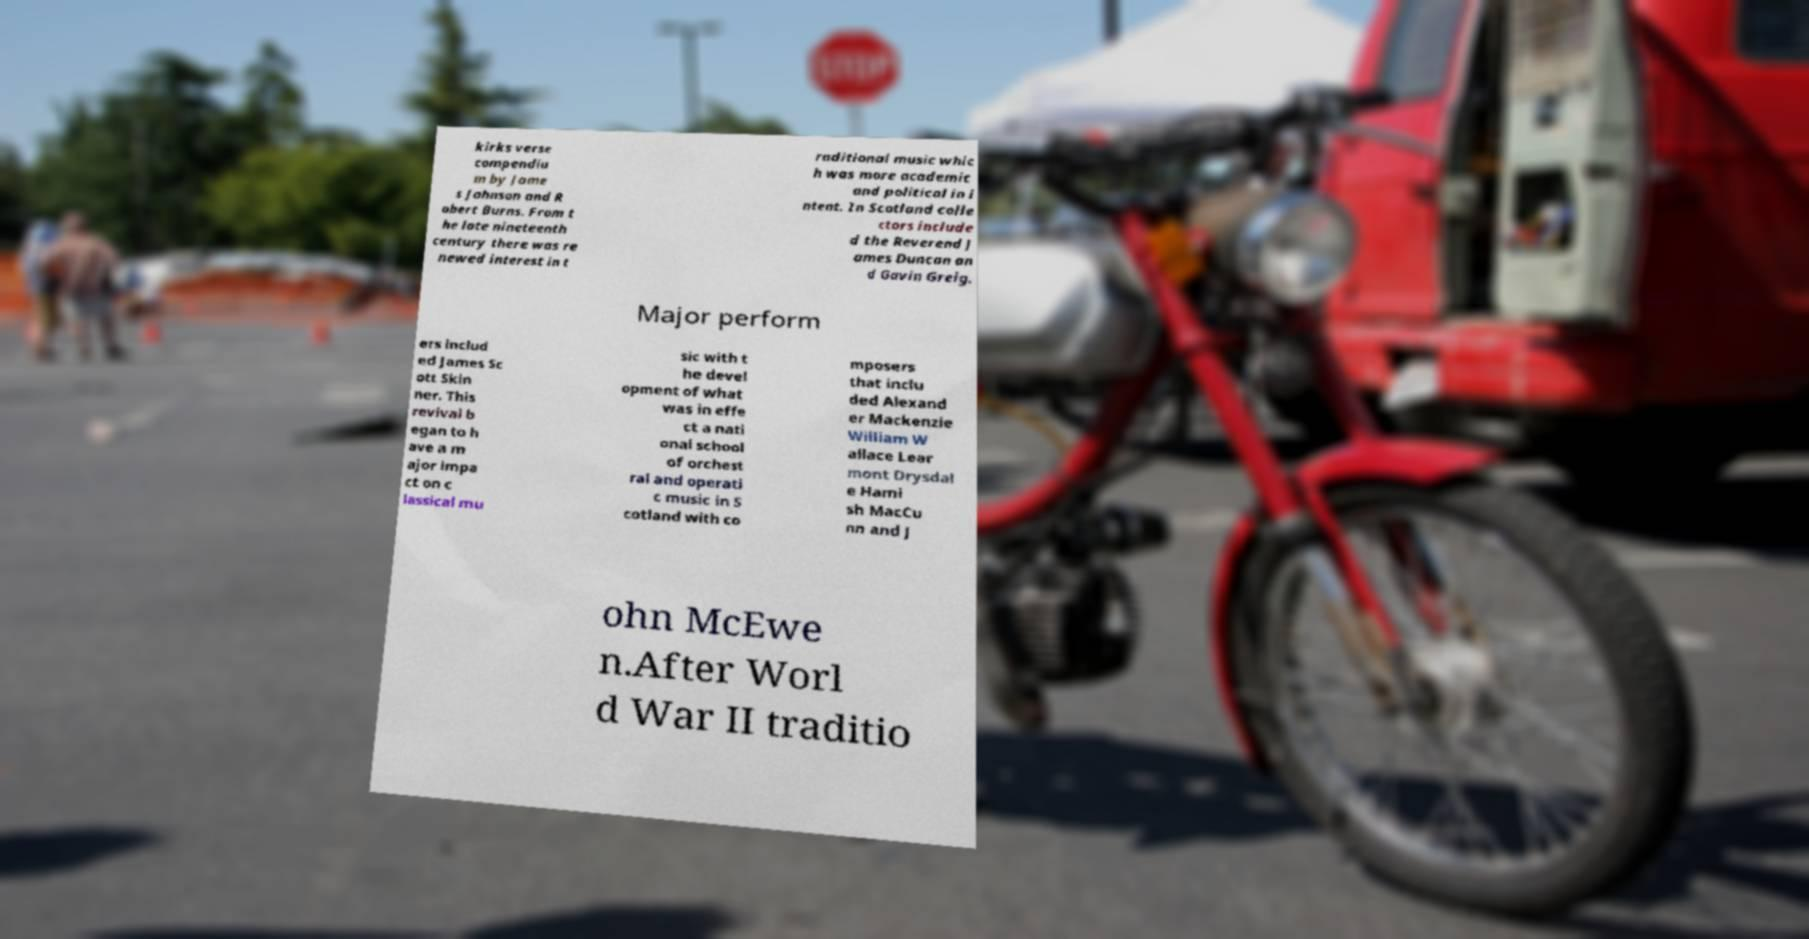What messages or text are displayed in this image? I need them in a readable, typed format. kirks verse compendiu m by Jame s Johnson and R obert Burns. From t he late nineteenth century there was re newed interest in t raditional music whic h was more academic and political in i ntent. In Scotland colle ctors include d the Reverend J ames Duncan an d Gavin Greig. Major perform ers includ ed James Sc ott Skin ner. This revival b egan to h ave a m ajor impa ct on c lassical mu sic with t he devel opment of what was in effe ct a nati onal school of orchest ral and operati c music in S cotland with co mposers that inclu ded Alexand er Mackenzie William W allace Lear mont Drysdal e Hami sh MacCu nn and J ohn McEwe n.After Worl d War II traditio 